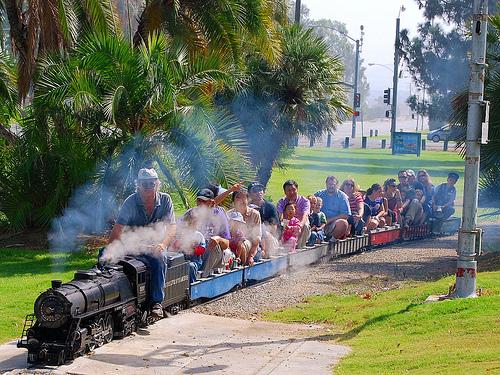What is the kids on?
Keep it brief. Train. From where is the smoke coming?
Short answer required. Train. What type of train is this?
Quick response, please. Small. 